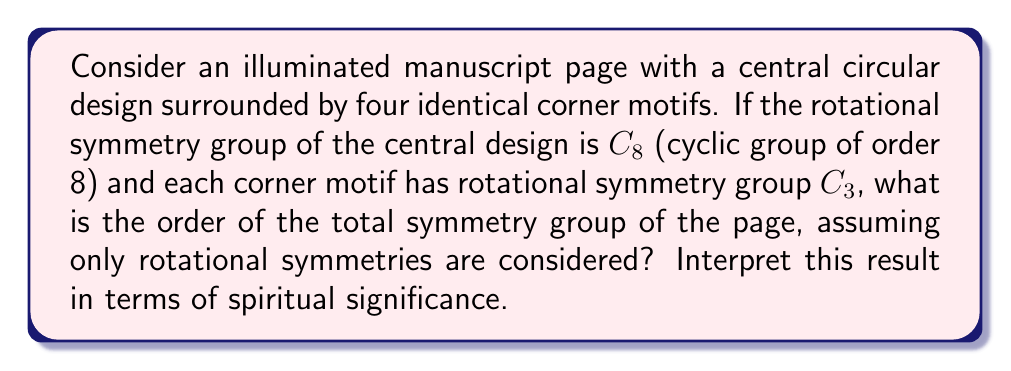Solve this math problem. Let's approach this step-by-step:

1) First, we need to understand the symmetry groups:
   - The central design has $C_8$ symmetry, meaning it has 8 rotational symmetries.
   - Each corner motif has $C_3$ symmetry, meaning it has 3 rotational symmetries.

2) The total symmetry group will be a direct product of these individual symmetry groups:
   $$G = C_8 \times (C_3)^4$$

3) To find the order of this group, we multiply the orders of its components:
   $$|G| = |C_8| \times |C_3|^4$$

4) We know that:
   $$|C_8| = 8$$
   $$|C_3| = 3$$

5) Substituting these values:
   $$|G| = 8 \times 3^4 = 8 \times 81 = 648$$

6) Spiritual interpretation: The number 648 can be factored as $2^3 \times 3^4$. In Christian numerology:
   - 3 represents the Holy Trinity
   - 4 often symbolizes the earthly realm (four corners of the earth)
   - 8 is associated with new beginnings or regeneration

   The presence of these numbers in the symmetry group's order could be interpreted as a representation of divine perfection (3) manifesting in the earthly realm (4), leading to spiritual renewal (8).
Answer: 648 